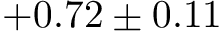Convert formula to latex. <formula><loc_0><loc_0><loc_500><loc_500>+ 0 . 7 2 \pm 0 . 1 1</formula> 